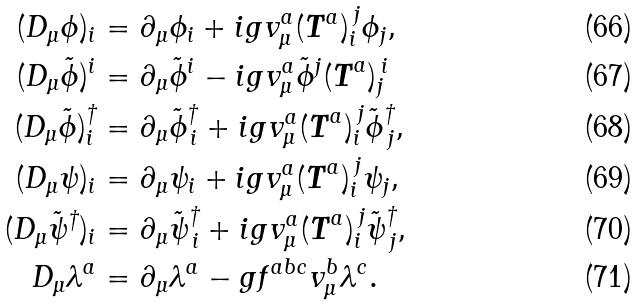<formula> <loc_0><loc_0><loc_500><loc_500>( D _ { \mu } \phi ) _ { i } & = \partial _ { \mu } \phi _ { i } + i g v ^ { a } _ { \mu } ( { \boldsymbol T } ^ { a } ) _ { i } ^ { \, j } \phi _ { j } , \\ ( D _ { \mu } \tilde { \phi } ) ^ { i } & = \partial _ { \mu } \tilde { \phi } ^ { i } - i g v ^ { a } _ { \mu } \tilde { \phi } ^ { j } ( { \boldsymbol T } ^ { a } ) _ { j } ^ { \, i } \\ ( D _ { \mu } \tilde { \phi } ) ^ { \dagger } _ { i } & = \partial _ { \mu } \tilde { \phi } ^ { \dagger } _ { \, i } + i g v ^ { a } _ { \mu } ( { \boldsymbol T } ^ { a } ) _ { i } ^ { \, j } \tilde { \phi } ^ { \dagger } _ { \, j } , \\ ( D _ { \mu } \psi ) _ { i } & = \partial _ { \mu } \psi _ { i } + i g v ^ { a } _ { \mu } ( { \boldsymbol T } ^ { a } ) _ { i } ^ { \, j } \psi _ { j } , \\ ( D _ { \mu } \tilde { \psi } ^ { \dagger } ) _ { i } & = \partial _ { \mu } \tilde { \psi } ^ { \dagger } _ { \, i } + i g v ^ { a } _ { \mu } ( { \boldsymbol T } ^ { a } ) _ { i } ^ { \, j } \tilde { \psi } ^ { \dagger } _ { \, j } , \\ D _ { \mu } \lambda ^ { a } & = \partial _ { \mu } \lambda ^ { a } - g f ^ { a b c } v ^ { b } _ { \mu } \lambda ^ { c } .</formula> 